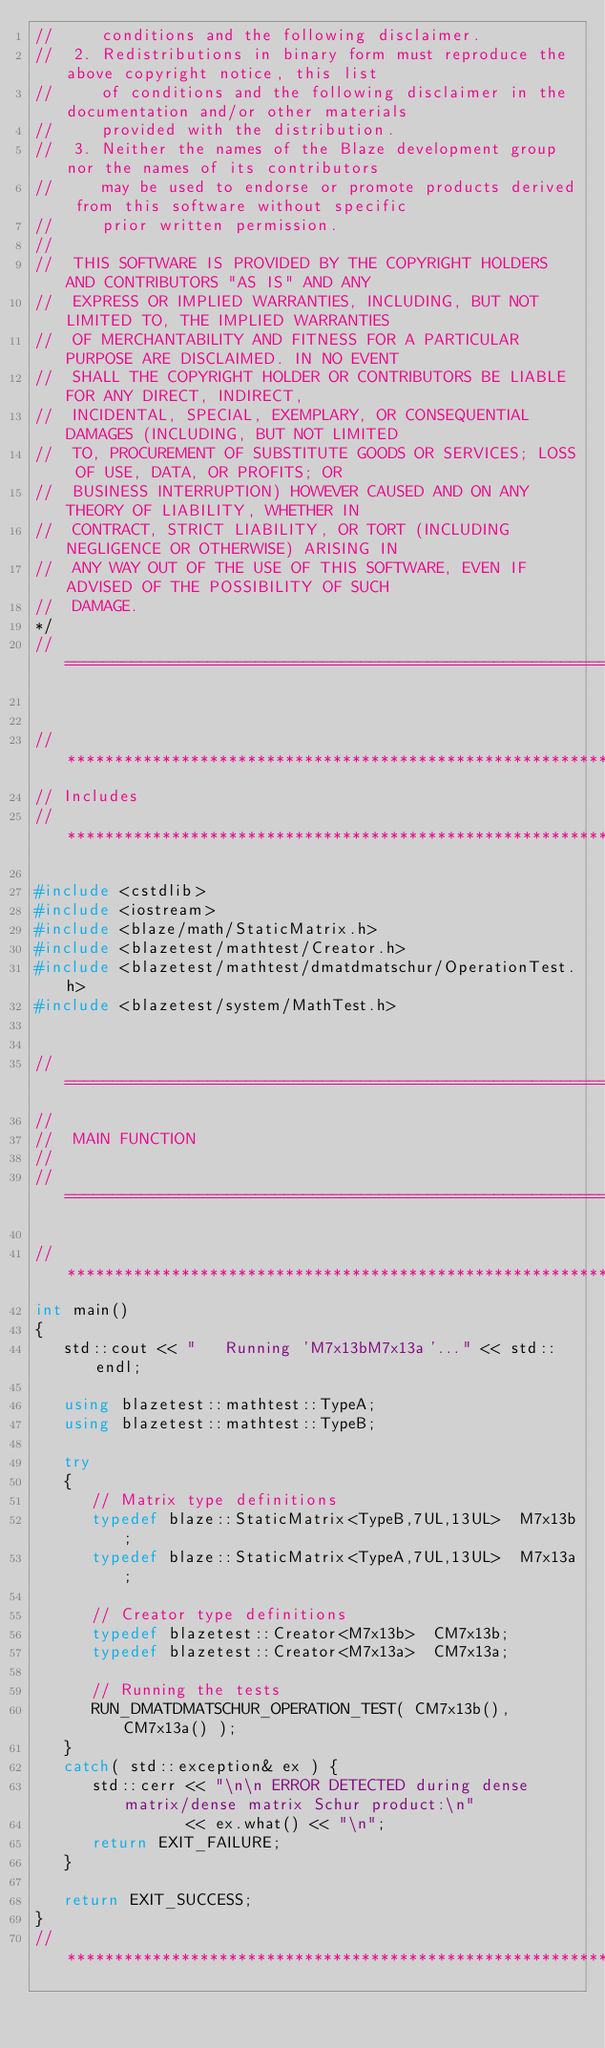Convert code to text. <code><loc_0><loc_0><loc_500><loc_500><_C++_>//     conditions and the following disclaimer.
//  2. Redistributions in binary form must reproduce the above copyright notice, this list
//     of conditions and the following disclaimer in the documentation and/or other materials
//     provided with the distribution.
//  3. Neither the names of the Blaze development group nor the names of its contributors
//     may be used to endorse or promote products derived from this software without specific
//     prior written permission.
//
//  THIS SOFTWARE IS PROVIDED BY THE COPYRIGHT HOLDERS AND CONTRIBUTORS "AS IS" AND ANY
//  EXPRESS OR IMPLIED WARRANTIES, INCLUDING, BUT NOT LIMITED TO, THE IMPLIED WARRANTIES
//  OF MERCHANTABILITY AND FITNESS FOR A PARTICULAR PURPOSE ARE DISCLAIMED. IN NO EVENT
//  SHALL THE COPYRIGHT HOLDER OR CONTRIBUTORS BE LIABLE FOR ANY DIRECT, INDIRECT,
//  INCIDENTAL, SPECIAL, EXEMPLARY, OR CONSEQUENTIAL DAMAGES (INCLUDING, BUT NOT LIMITED
//  TO, PROCUREMENT OF SUBSTITUTE GOODS OR SERVICES; LOSS OF USE, DATA, OR PROFITS; OR
//  BUSINESS INTERRUPTION) HOWEVER CAUSED AND ON ANY THEORY OF LIABILITY, WHETHER IN
//  CONTRACT, STRICT LIABILITY, OR TORT (INCLUDING NEGLIGENCE OR OTHERWISE) ARISING IN
//  ANY WAY OUT OF THE USE OF THIS SOFTWARE, EVEN IF ADVISED OF THE POSSIBILITY OF SUCH
//  DAMAGE.
*/
//=================================================================================================


//*************************************************************************************************
// Includes
//*************************************************************************************************

#include <cstdlib>
#include <iostream>
#include <blaze/math/StaticMatrix.h>
#include <blazetest/mathtest/Creator.h>
#include <blazetest/mathtest/dmatdmatschur/OperationTest.h>
#include <blazetest/system/MathTest.h>


//=================================================================================================
//
//  MAIN FUNCTION
//
//=================================================================================================

//*************************************************************************************************
int main()
{
   std::cout << "   Running 'M7x13bM7x13a'..." << std::endl;

   using blazetest::mathtest::TypeA;
   using blazetest::mathtest::TypeB;

   try
   {
      // Matrix type definitions
      typedef blaze::StaticMatrix<TypeB,7UL,13UL>  M7x13b;
      typedef blaze::StaticMatrix<TypeA,7UL,13UL>  M7x13a;

      // Creator type definitions
      typedef blazetest::Creator<M7x13b>  CM7x13b;
      typedef blazetest::Creator<M7x13a>  CM7x13a;

      // Running the tests
      RUN_DMATDMATSCHUR_OPERATION_TEST( CM7x13b(), CM7x13a() );
   }
   catch( std::exception& ex ) {
      std::cerr << "\n\n ERROR DETECTED during dense matrix/dense matrix Schur product:\n"
                << ex.what() << "\n";
      return EXIT_FAILURE;
   }

   return EXIT_SUCCESS;
}
//*************************************************************************************************
</code> 